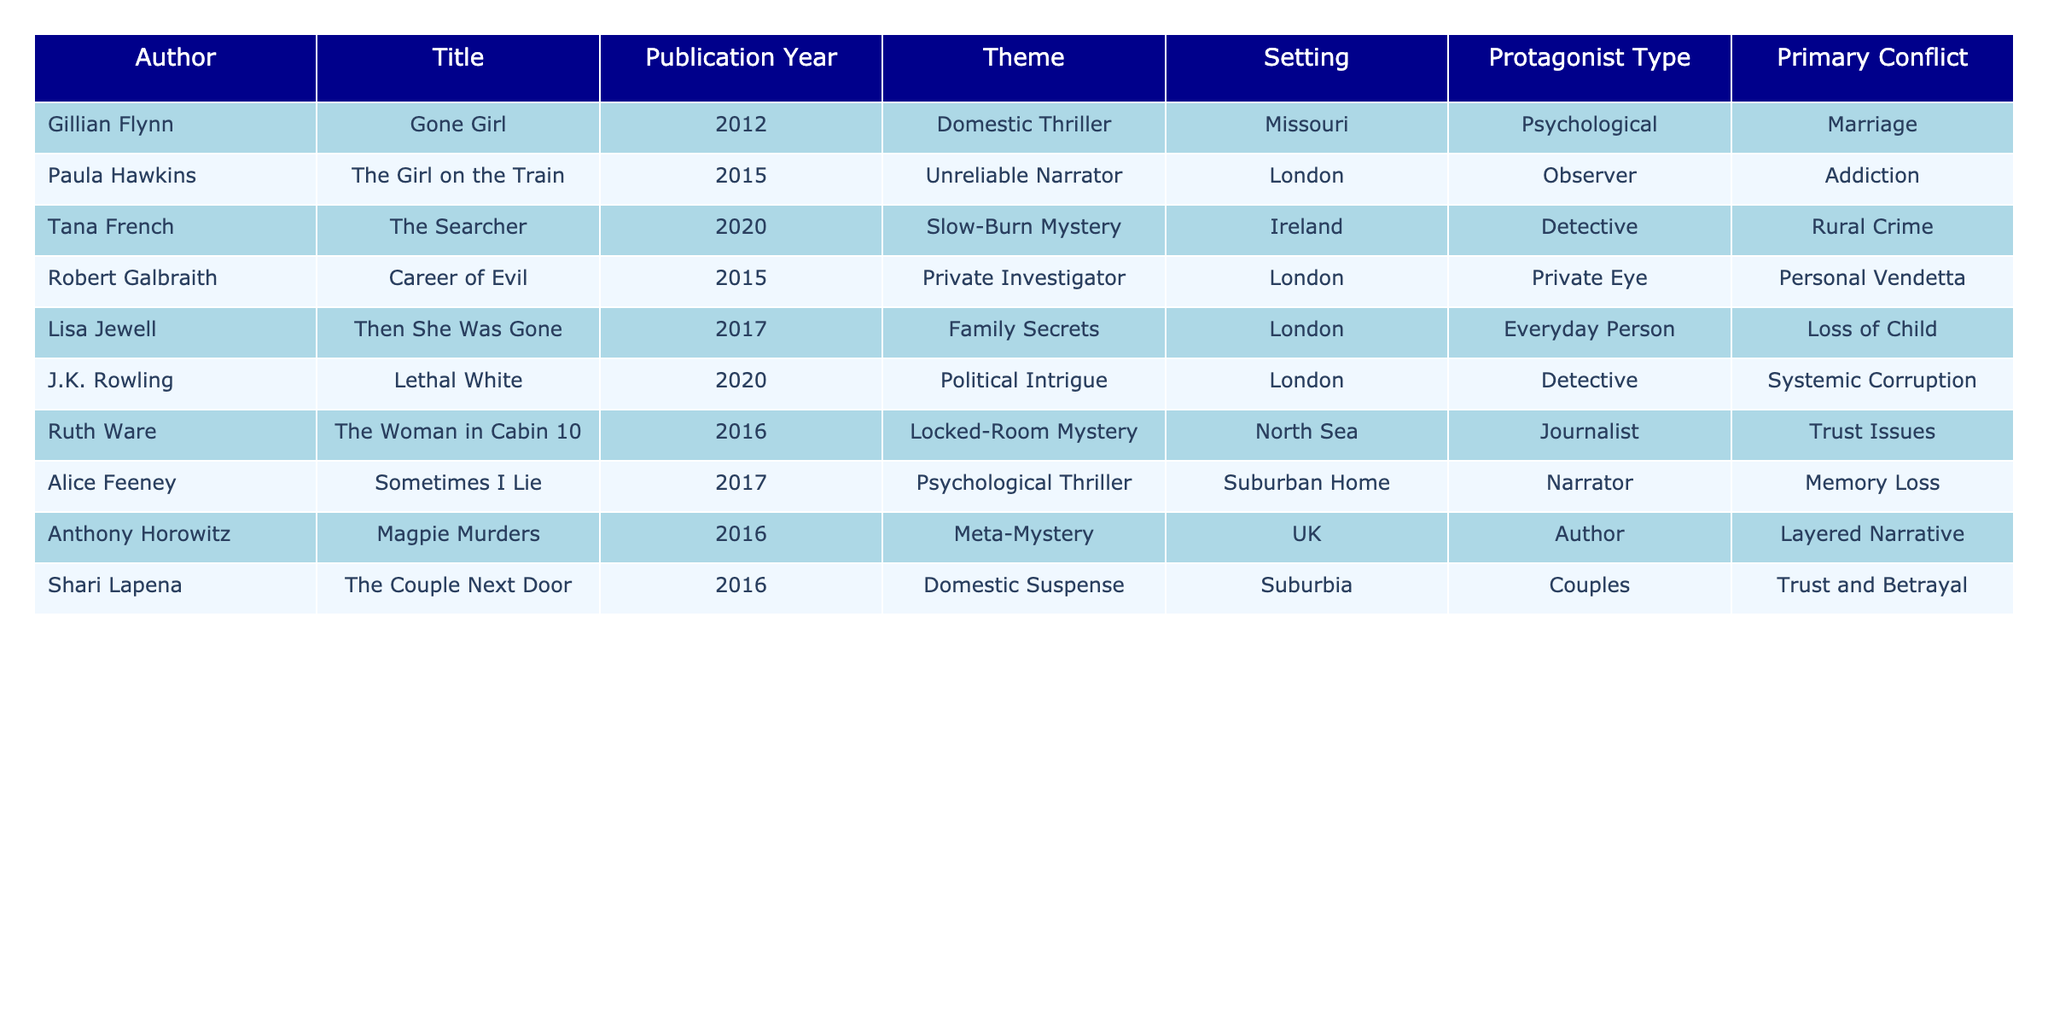What are the themes of the novels published in 2017? By referring to the table, we can locate the publication year column and find the titles published in 2017: "Then She Was Gone" and "Sometimes I Lie." Their respective themes are "Family Secrets" and "Psychological Thriller."
Answer: Family Secrets, Psychological Thriller Which novel features a private investigator as the protagonist? Looking through the protagonist type column, we find "Career of Evil" by Robert Galbraith, which lists "Private Eye" as the protagonist type.
Answer: Career of Evil How many novels are set in London? We can count the entries in the setting column that mention London. The novels are "The Girl on the Train," "Career of Evil," "Then She Was Gone," and "Lethal White," totaling four.
Answer: 4 Is "Gone Girl" categorized as a psychological thriller? Checking the theme of "Gone Girl" in the table, we see it is listed under "Domestic Thriller," not "Psychological Thriller."
Answer: No What is the primary conflict in "The Woman in Cabin 10"? The primary conflict for "The Woman in Cabin 10" as shown in the table is "Trust Issues."
Answer: Trust Issues Which theme appears most frequently in the table? By examining the theme column, we see "Psychological Thriller" and "Domestic Thriller" appear once, while "Domestic Suspense" and "Slow-Burn Mystery" appear once as well, leaving "Unreliable Narrator," "Private Investigator," "Family Secrets," and "Locked-Room Mystery" similarly counted. Therefore, it appears there is no dominant theme with a frequency over others; each theme is unique among the titles.
Answer: No dominant theme What year did the novel "Magpie Murders" get published? The table indicates that "Magpie Murders" was published in 2016.
Answer: 2016 Which two novels explore themes involving family? Referring back to the theme column, we can identify "Then She Was Gone" (Family Secrets) and evaluate if any other novel discusses family; there are no other mentions that align directly with a family theme, so only the one fits.
Answer: Then She Was Gone Are there more mystery novels featuring female protagonists than male protagonists? By reviewing the protagonist type column: the female protagonists are "Psychological," "Everyday Person," and "Journalist"—totaling three instances, while "Private Eye" and "Author" can be attributed to male—totally two instances. Thus, there’s a majority of female leads.
Answer: Yes Which novel's setting is rural Ireland and which year was it published? The table shows "The Searcher" set in Ireland and published in 2020.
Answer: The Searcher, 2020 How many unique themes are listed in this table? By analyzing the themes column, we can count the unique entries: Domestic Thriller, Unreliable Narrator, Slow-Burn Mystery, Private Investigator, Family Secrets, Political Intrigue, Locked-Room Mystery, Psychological Thriller, Domestic Suspense, and Meta-Mystery—totalling ten unique themes.
Answer: 10 